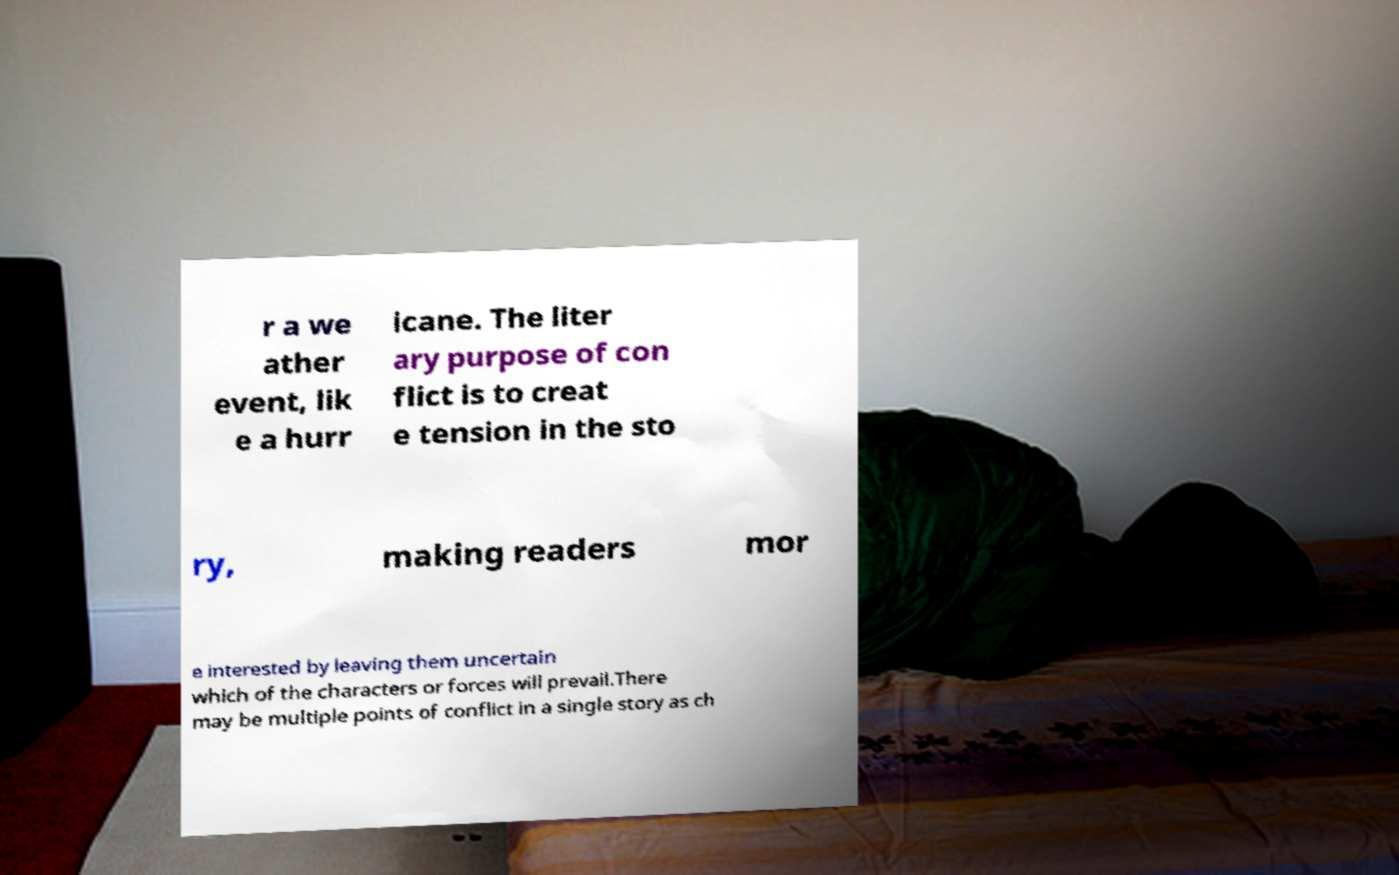I need the written content from this picture converted into text. Can you do that? r a we ather event, lik e a hurr icane. The liter ary purpose of con flict is to creat e tension in the sto ry, making readers mor e interested by leaving them uncertain which of the characters or forces will prevail.There may be multiple points of conflict in a single story as ch 